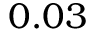<formula> <loc_0><loc_0><loc_500><loc_500>0 . 0 3</formula> 